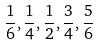Convert formula to latex. <formula><loc_0><loc_0><loc_500><loc_500>\frac { 1 } { 6 } , \frac { 1 } { 4 } , \frac { 1 } { 2 } , \frac { 3 } { 4 } , \frac { 5 } { 6 }</formula> 